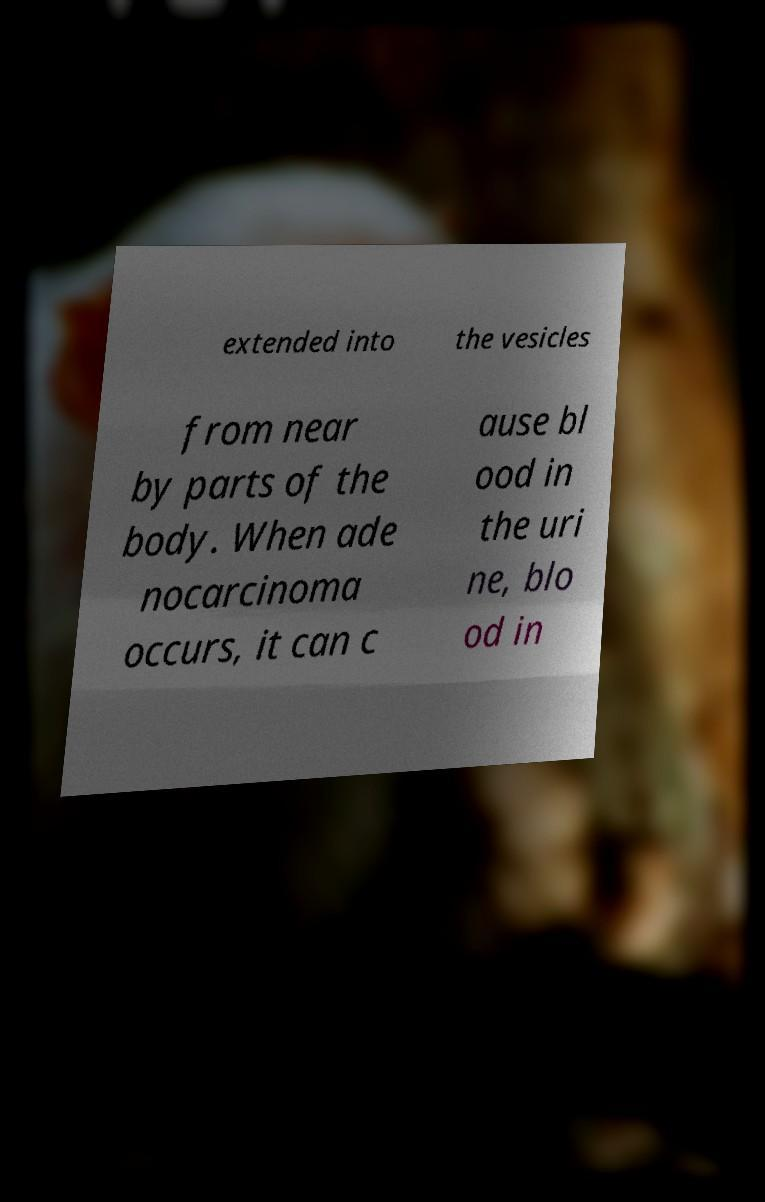Please read and relay the text visible in this image. What does it say? extended into the vesicles from near by parts of the body. When ade nocarcinoma occurs, it can c ause bl ood in the uri ne, blo od in 